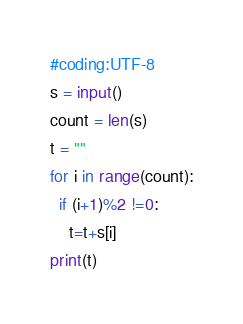Convert code to text. <code><loc_0><loc_0><loc_500><loc_500><_Python_>#coding:UTF-8
s = input()
count = len(s)
t = ""
for i in range(count):
  if (i+1)%2 !=0:
    t=t+s[i]
print(t)</code> 